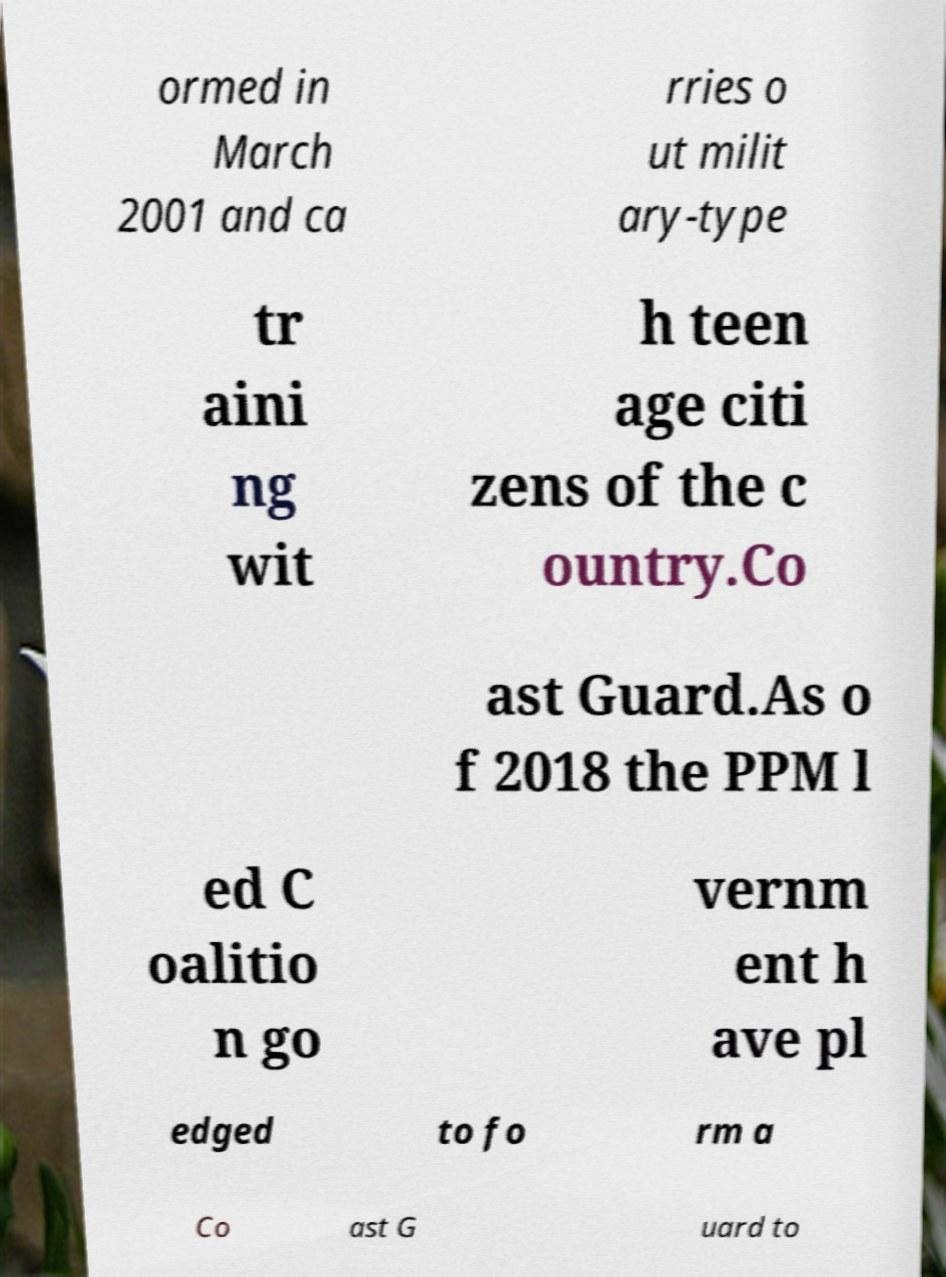What messages or text are displayed in this image? I need them in a readable, typed format. ormed in March 2001 and ca rries o ut milit ary-type tr aini ng wit h teen age citi zens of the c ountry.Co ast Guard.As o f 2018 the PPM l ed C oalitio n go vernm ent h ave pl edged to fo rm a Co ast G uard to 